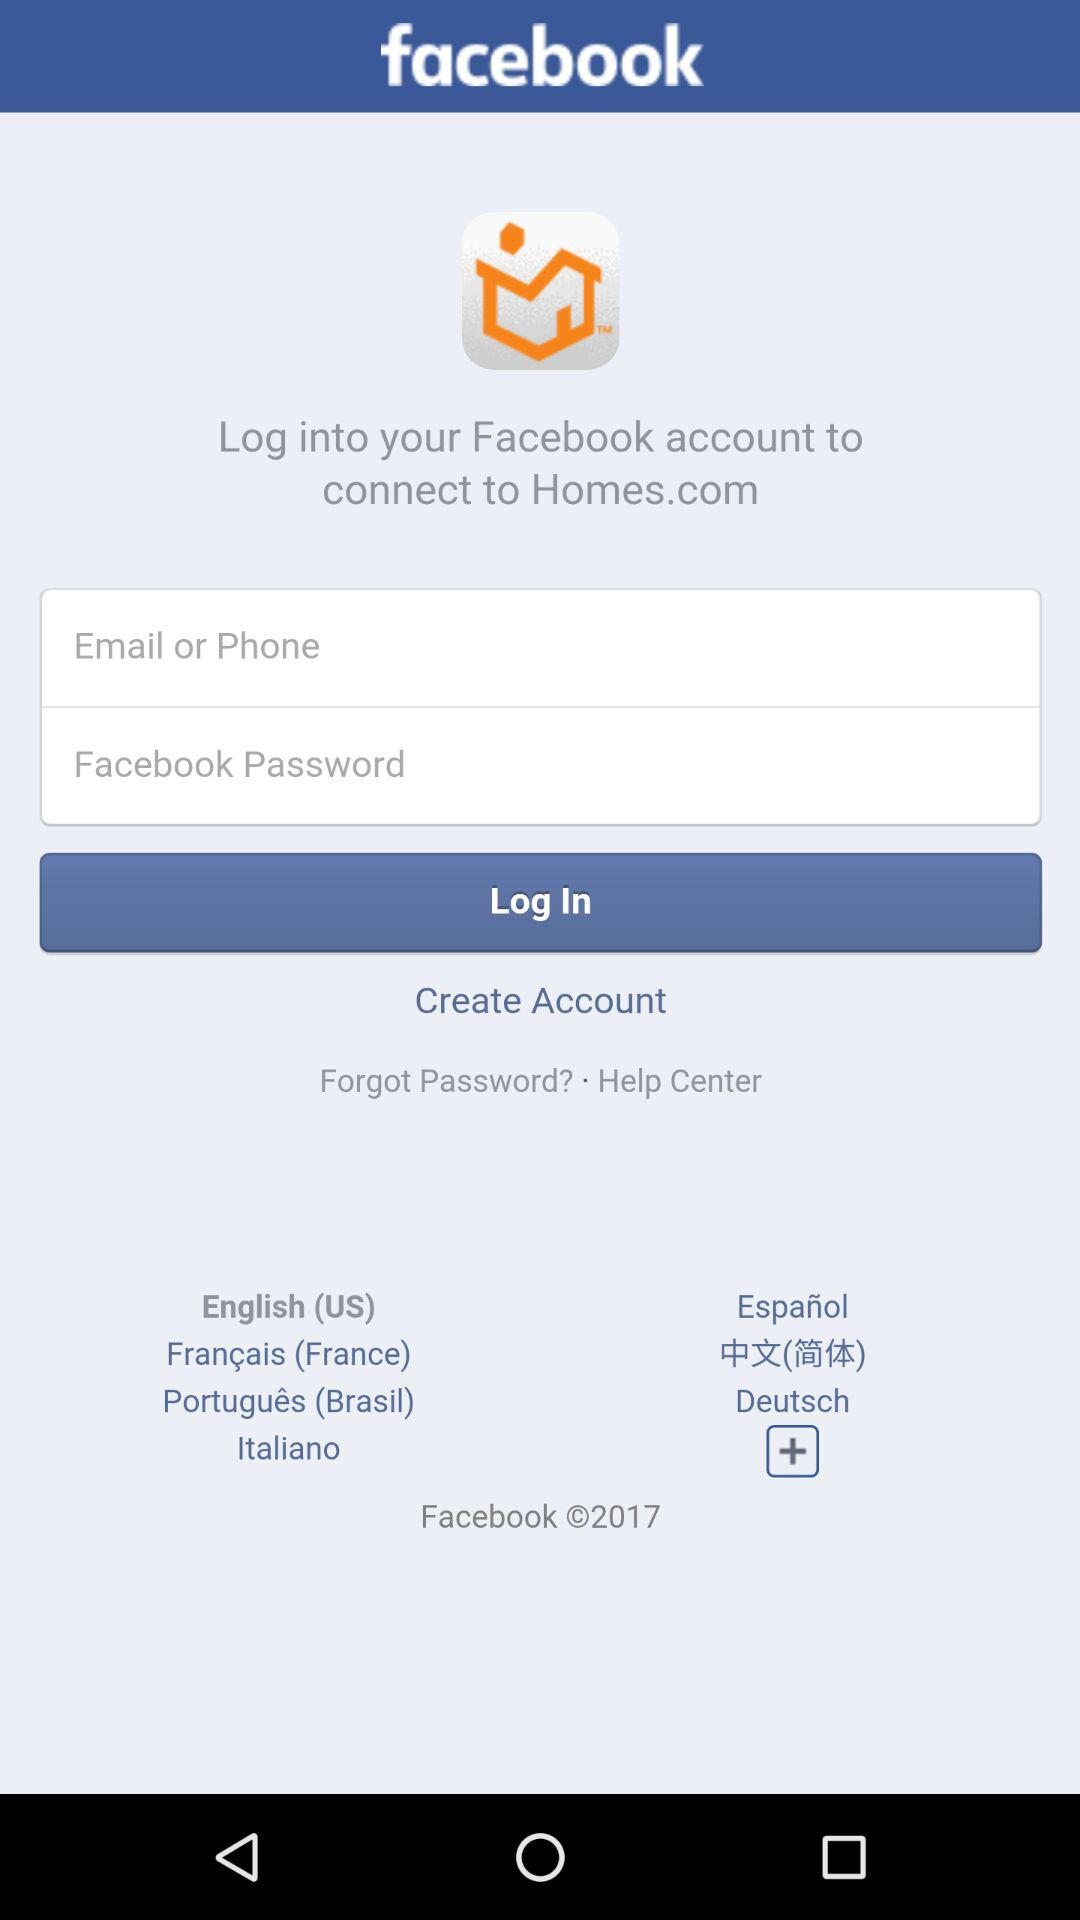How many languages are available for this login screen?
Answer the question using a single word or phrase. 7 